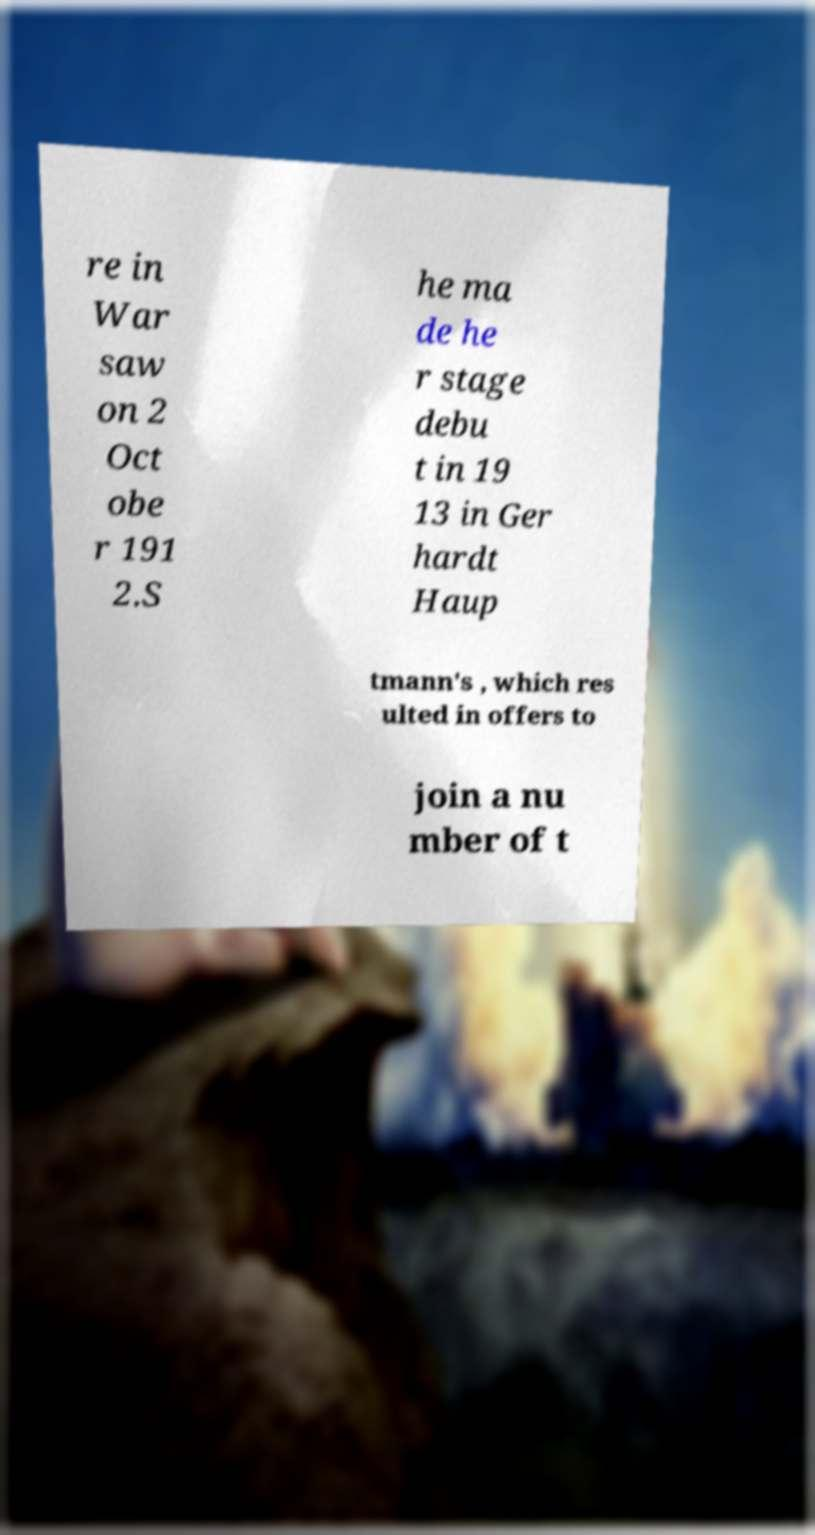I need the written content from this picture converted into text. Can you do that? re in War saw on 2 Oct obe r 191 2.S he ma de he r stage debu t in 19 13 in Ger hardt Haup tmann's , which res ulted in offers to join a nu mber of t 